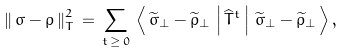<formula> <loc_0><loc_0><loc_500><loc_500>\left \| \, \sigma - \rho \, \right \| ^ { 2 } _ { T } \, = \, \sum _ { t \, \geq \, 0 } \, \left \langle \, \widetilde { \sigma } _ { \bot } - \widetilde { \rho } _ { \bot } \, \left | \, \widehat { T } ^ { t } \, \right | \, \widetilde { \sigma } _ { \bot } - \widetilde { \rho } _ { \bot } \, \right \rangle ,</formula> 